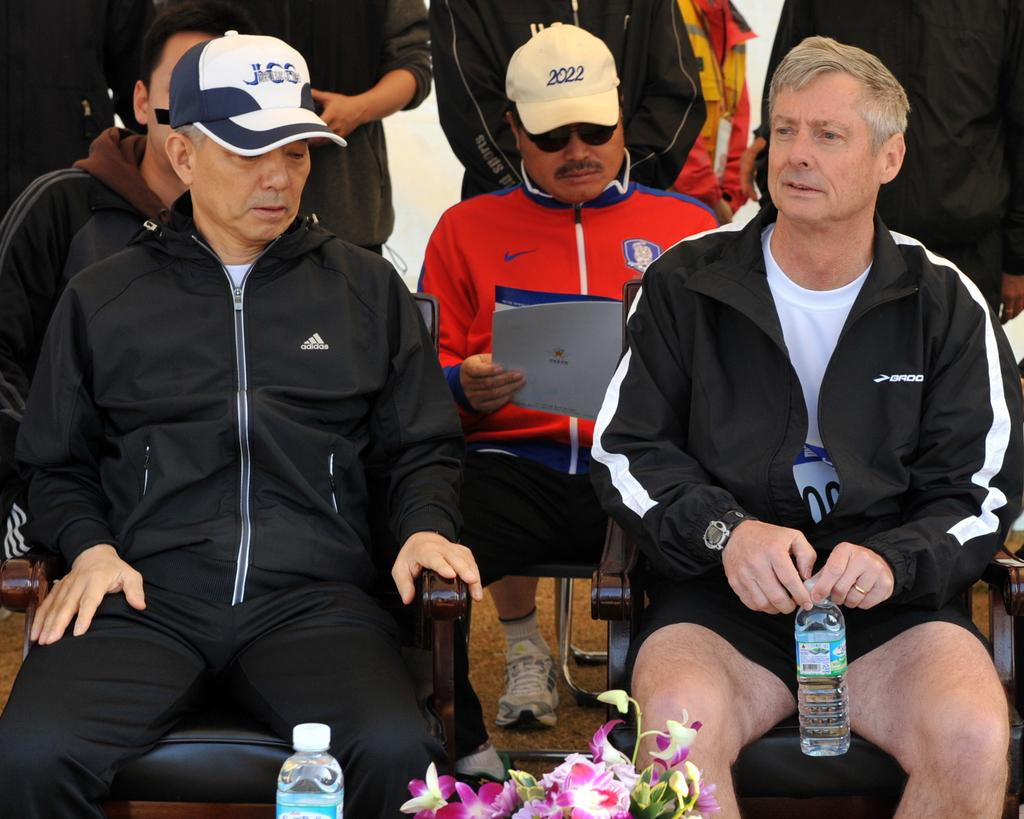<image>
Write a terse but informative summary of the picture. One of the men seated is wearing a hat with 2022 written on it. 